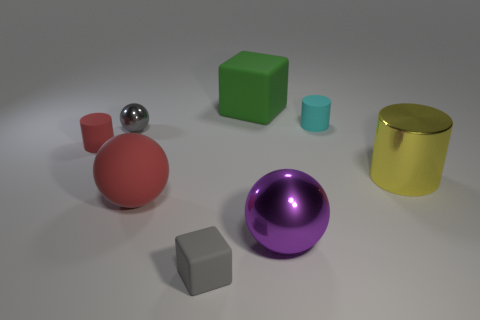Which objects in the picture appear to be the glossiest? The silver sphere and the golden cylinder appear to be the glossiest objects in the image due to their reflective surfaces. 